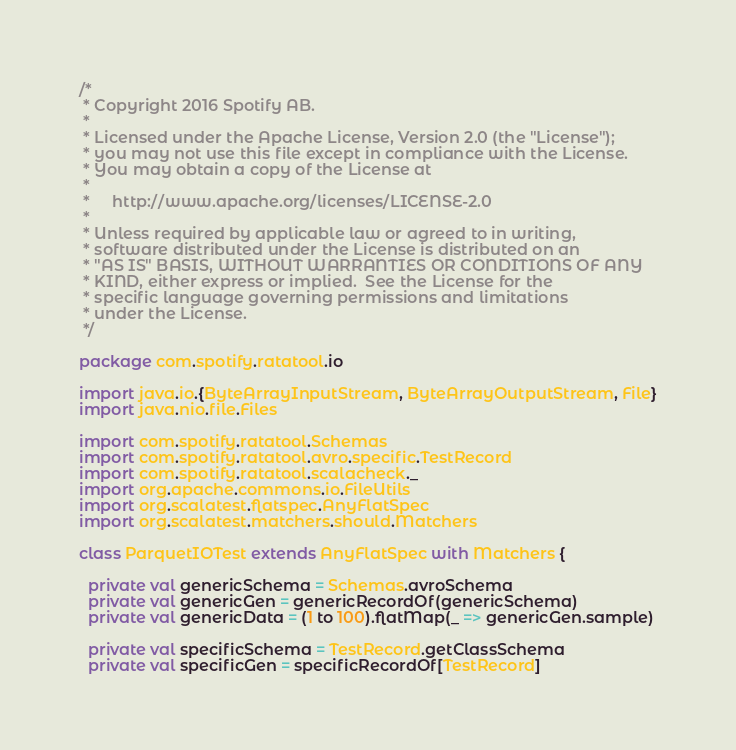Convert code to text. <code><loc_0><loc_0><loc_500><loc_500><_Scala_>/*
 * Copyright 2016 Spotify AB.
 *
 * Licensed under the Apache License, Version 2.0 (the "License");
 * you may not use this file except in compliance with the License.
 * You may obtain a copy of the License at
 *
 *     http://www.apache.org/licenses/LICENSE-2.0
 *
 * Unless required by applicable law or agreed to in writing,
 * software distributed under the License is distributed on an
 * "AS IS" BASIS, WITHOUT WARRANTIES OR CONDITIONS OF ANY
 * KIND, either express or implied.  See the License for the
 * specific language governing permissions and limitations
 * under the License.
 */

package com.spotify.ratatool.io

import java.io.{ByteArrayInputStream, ByteArrayOutputStream, File}
import java.nio.file.Files

import com.spotify.ratatool.Schemas
import com.spotify.ratatool.avro.specific.TestRecord
import com.spotify.ratatool.scalacheck._
import org.apache.commons.io.FileUtils
import org.scalatest.flatspec.AnyFlatSpec
import org.scalatest.matchers.should.Matchers

class ParquetIOTest extends AnyFlatSpec with Matchers {

  private val genericSchema = Schemas.avroSchema
  private val genericGen = genericRecordOf(genericSchema)
  private val genericData = (1 to 100).flatMap(_ => genericGen.sample)

  private val specificSchema = TestRecord.getClassSchema
  private val specificGen = specificRecordOf[TestRecord]</code> 